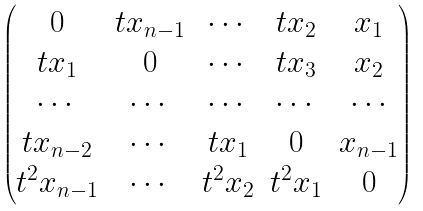<formula> <loc_0><loc_0><loc_500><loc_500>\begin{pmatrix} 0 & t x _ { n - 1 } & \cdots & t x _ { 2 } & x _ { 1 } \\ t x _ { 1 } & 0 & \cdots & t x _ { 3 } & x _ { 2 } \\ \cdots & \cdots & \cdots & \cdots & \cdots \\ t x _ { n - 2 } & \cdots & t x _ { 1 } & 0 & x _ { n - 1 } \\ t ^ { 2 } x _ { n - 1 } & \cdots & t ^ { 2 } x _ { 2 } & t ^ { 2 } x _ { 1 } & 0 \end{pmatrix}</formula> 